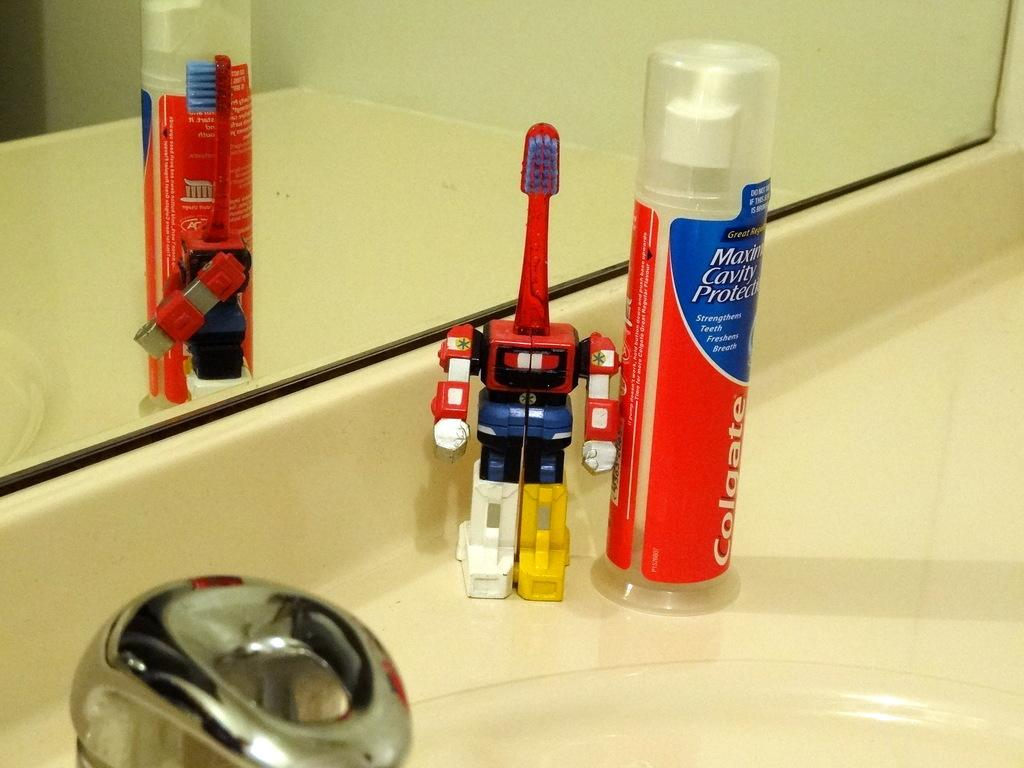<image>
Render a clear and concise summary of the photo. Red tube of Colgate next to a robotic tooth brush. 